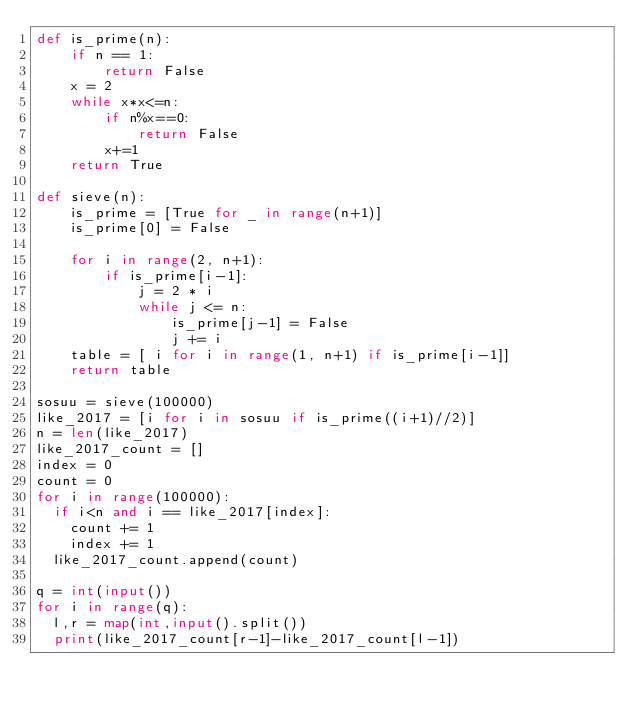<code> <loc_0><loc_0><loc_500><loc_500><_Python_>def is_prime(n):
    if n == 1: 
        return False
    x = 2
    while x*x<=n:
        if n%x==0:
            return False
        x+=1
    return True

def sieve(n):
    is_prime = [True for _ in range(n+1)]
    is_prime[0] = False

    for i in range(2, n+1):
        if is_prime[i-1]:
            j = 2 * i
            while j <= n:
                is_prime[j-1] = False
                j += i
    table = [ i for i in range(1, n+1) if is_prime[i-1]]
    return table

sosuu = sieve(100000)
like_2017 = [i for i in sosuu if is_prime((i+1)//2)]
n = len(like_2017)
like_2017_count = []
index = 0
count = 0
for i in range(100000):
  if i<n and i == like_2017[index]:
    count += 1
    index += 1
  like_2017_count.append(count)
  
q = int(input())
for i in range(q):
  l,r = map(int,input().split())
  print(like_2017_count[r-1]-like_2017_count[l-1])</code> 